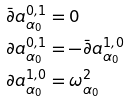<formula> <loc_0><loc_0><loc_500><loc_500>\bar { \partial } a ^ { 0 , 1 } _ { \alpha _ { 0 } } & = 0 \\ { \partial } a ^ { 0 , 1 } _ { \alpha _ { 0 } } & = - \bar { \partial } a ^ { 1 , 0 } _ { \alpha _ { 0 } } \\ \partial a ^ { 1 , 0 } _ { \alpha _ { 0 } } & = \omega ^ { 2 } _ { \alpha _ { 0 } }</formula> 